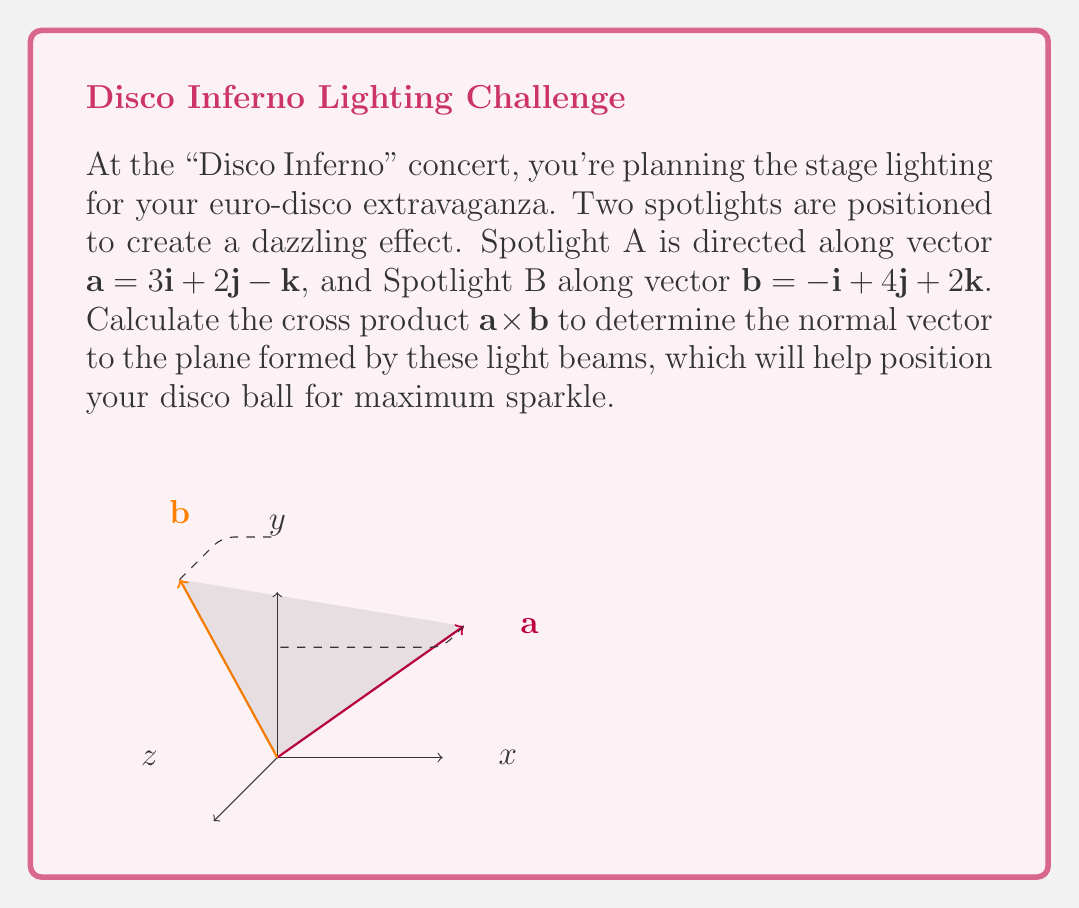Provide a solution to this math problem. To find the cross product $\mathbf{a} \times \mathbf{b}$, we'll use the formula:

$$\mathbf{a} \times \mathbf{b} = (a_y b_z - a_z b_y)\mathbf{i} - (a_x b_z - a_z b_x)\mathbf{j} + (a_x b_y - a_y b_x)\mathbf{k}$$

Where:
$\mathbf{a} = 3\mathbf{i} + 2\mathbf{j} - \mathbf{k}$, so $a_x = 3$, $a_y = 2$, $a_z = -1$
$\mathbf{b} = -\mathbf{i} + 4\mathbf{j} + 2\mathbf{k}$, so $b_x = -1$, $b_y = 4$, $b_z = 2$

Let's calculate each component:

1) $i$ component: $(a_y b_z - a_z b_y) = (2 \cdot 2 - (-1) \cdot 4) = 4 + 4 = 8$

2) $j$ component: $-(a_x b_z - a_z b_x) = -(3 \cdot 2 - (-1) \cdot (-1)) = -(6 - 1) = -5$

3) $k$ component: $(a_x b_y - a_y b_x) = (3 \cdot 4 - 2 \cdot (-1)) = 12 + 2 = 14$

Therefore, $\mathbf{a} \times \mathbf{b} = 8\mathbf{i} - 5\mathbf{j} + 14\mathbf{k}$
Answer: $8\mathbf{i} - 5\mathbf{j} + 14\mathbf{k}$ 